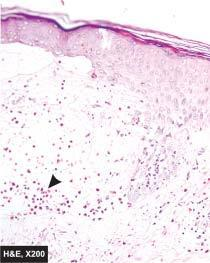does disse show non-acantholytic subepidermal bulla containing microabscess of eosinophils?
Answer the question using a single word or phrase. No 